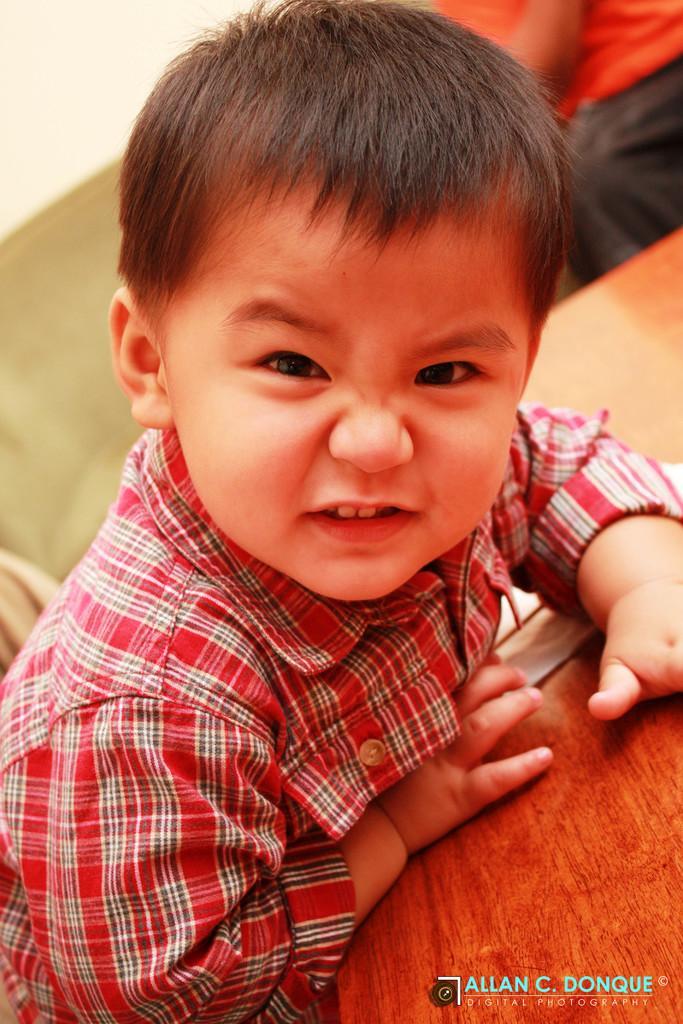In one or two sentences, can you explain what this image depicts? In this image I can see the person with the red, black and white color dress. In-front of the person I can see the table. In the background I can see another person with the dress. 